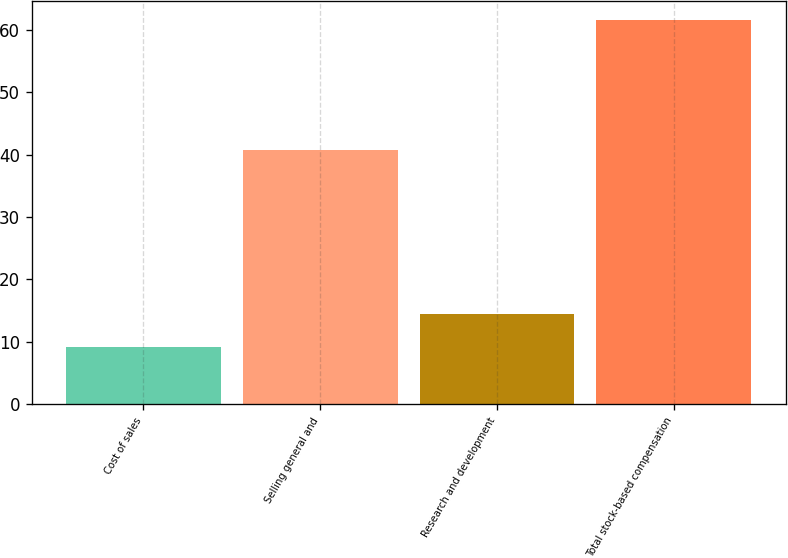Convert chart. <chart><loc_0><loc_0><loc_500><loc_500><bar_chart><fcel>Cost of sales<fcel>Selling general and<fcel>Research and development<fcel>Total stock-based compensation<nl><fcel>9.2<fcel>40.7<fcel>14.44<fcel>61.6<nl></chart> 